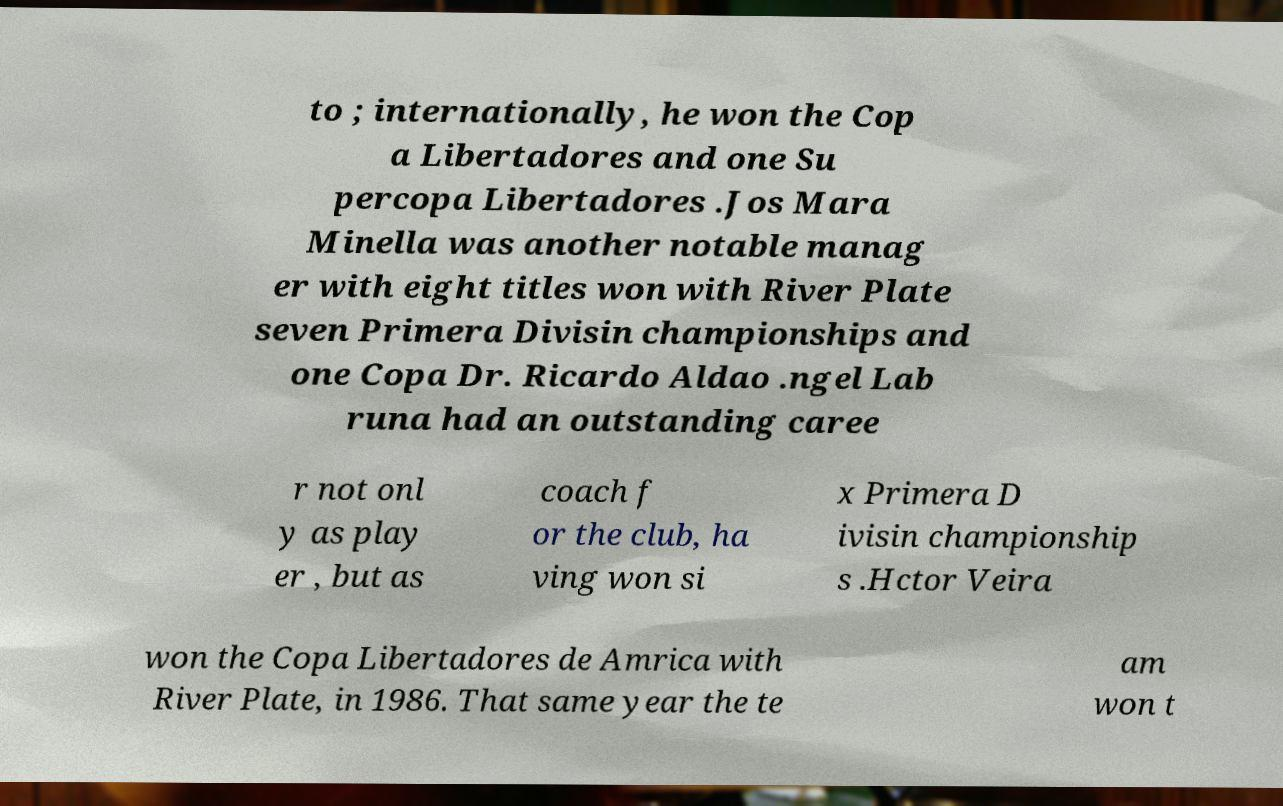Could you extract and type out the text from this image? to ; internationally, he won the Cop a Libertadores and one Su percopa Libertadores .Jos Mara Minella was another notable manag er with eight titles won with River Plate seven Primera Divisin championships and one Copa Dr. Ricardo Aldao .ngel Lab runa had an outstanding caree r not onl y as play er , but as coach f or the club, ha ving won si x Primera D ivisin championship s .Hctor Veira won the Copa Libertadores de Amrica with River Plate, in 1986. That same year the te am won t 